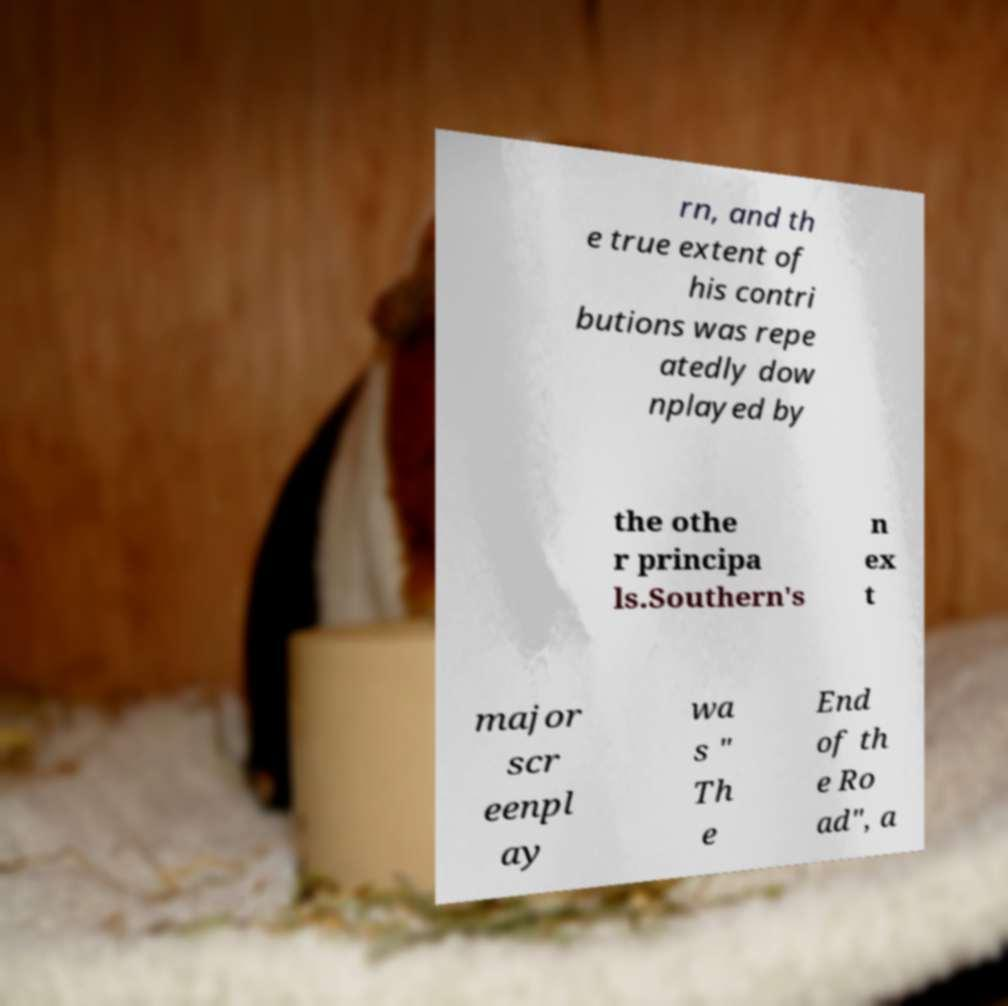What messages or text are displayed in this image? I need them in a readable, typed format. rn, and th e true extent of his contri butions was repe atedly dow nplayed by the othe r principa ls.Southern's n ex t major scr eenpl ay wa s " Th e End of th e Ro ad", a 